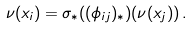Convert formula to latex. <formula><loc_0><loc_0><loc_500><loc_500>\nu ( x _ { i } ) = \sigma _ { \ast } ( ( \phi _ { i j } ) _ { \ast } ) ( \nu ( x _ { j } ) ) \, .</formula> 